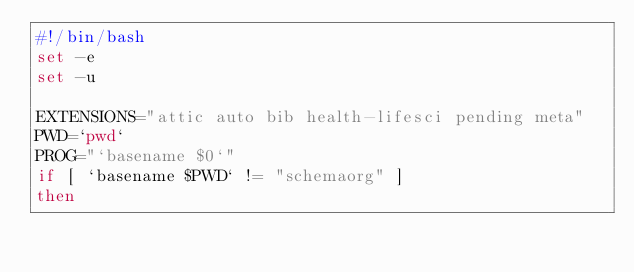<code> <loc_0><loc_0><loc_500><loc_500><_Bash_>#!/bin/bash
set -e
set -u

EXTENSIONS="attic auto bib health-lifesci pending meta"
PWD=`pwd`
PROG="`basename $0`"
if [ `basename $PWD` != "schemaorg" ]
then</code> 